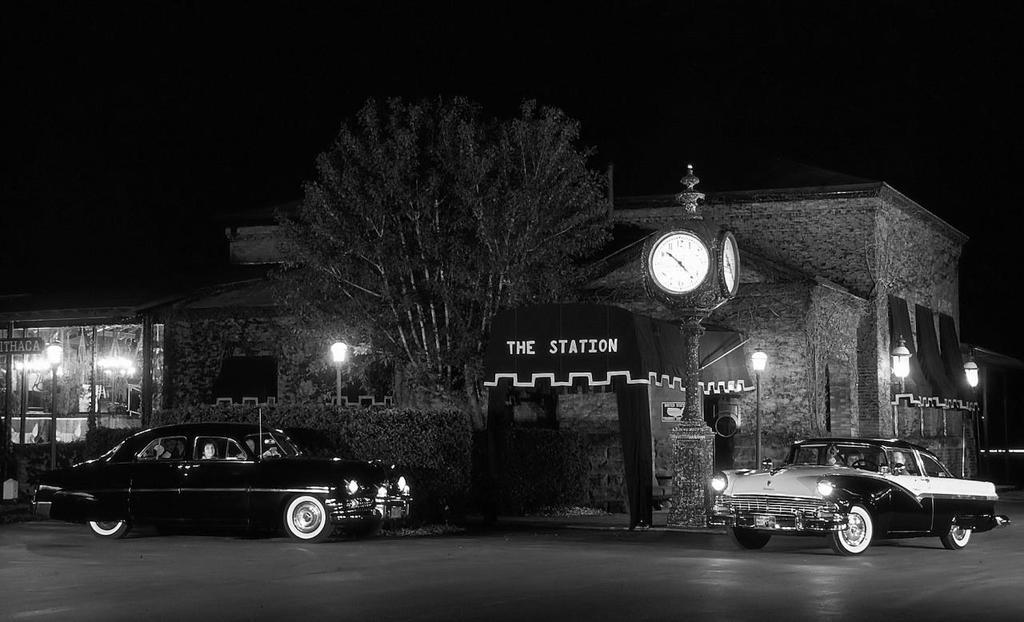In one or two sentences, can you explain what this image depicts? In the foreground of this image, at the bottom, there is a road and we can also see two cars on it. In the middle, there is a building and ashed like an object, plants, a tree, lights and a clock. At the top, there is the dark sky. 